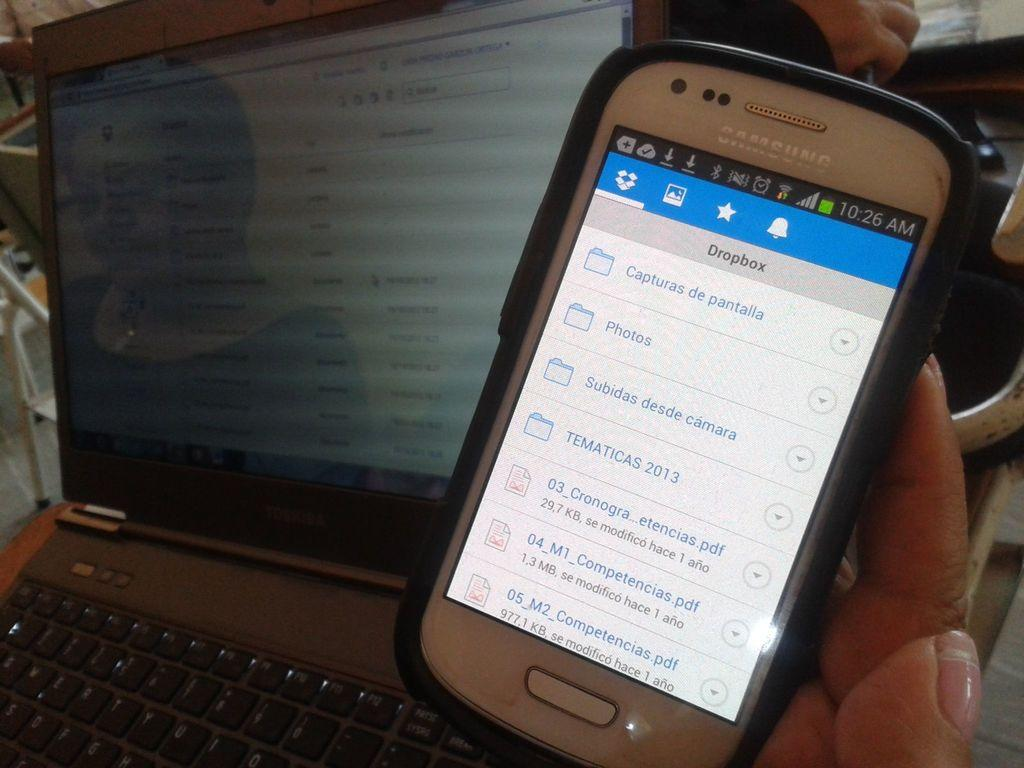<image>
Share a concise interpretation of the image provided. Person holding a phone with a screen that says Dropbox. 